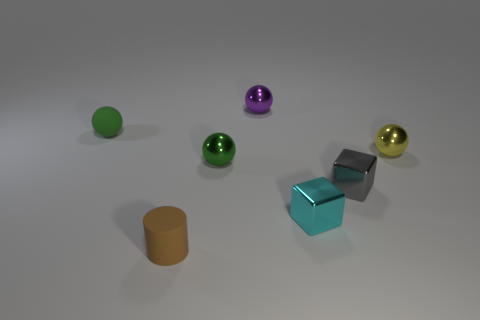How many green spheres must be subtracted to get 1 green spheres? 1 Subtract all gray balls. Subtract all yellow blocks. How many balls are left? 4 Add 1 brown metallic cubes. How many objects exist? 8 Subtract all cylinders. How many objects are left? 6 Add 6 matte spheres. How many matte spheres are left? 7 Add 4 big purple cylinders. How many big purple cylinders exist? 4 Subtract 1 yellow balls. How many objects are left? 6 Subtract all gray objects. Subtract all tiny purple things. How many objects are left? 5 